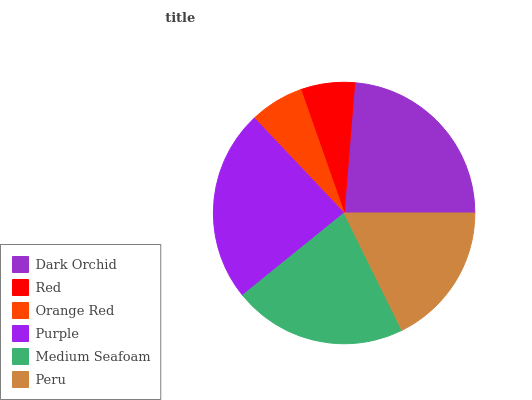Is Red the minimum?
Answer yes or no. Yes. Is Purple the maximum?
Answer yes or no. Yes. Is Orange Red the minimum?
Answer yes or no. No. Is Orange Red the maximum?
Answer yes or no. No. Is Orange Red greater than Red?
Answer yes or no. Yes. Is Red less than Orange Red?
Answer yes or no. Yes. Is Red greater than Orange Red?
Answer yes or no. No. Is Orange Red less than Red?
Answer yes or no. No. Is Medium Seafoam the high median?
Answer yes or no. Yes. Is Peru the low median?
Answer yes or no. Yes. Is Purple the high median?
Answer yes or no. No. Is Purple the low median?
Answer yes or no. No. 